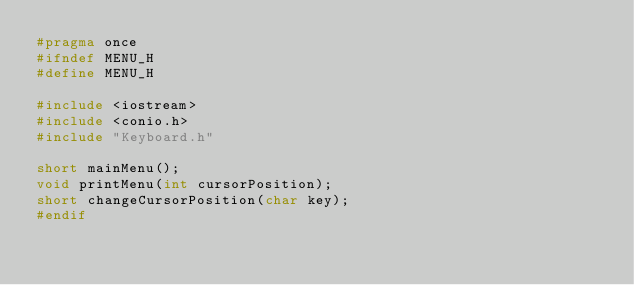<code> <loc_0><loc_0><loc_500><loc_500><_C_>#pragma once
#ifndef MENU_H
#define MENU_H

#include <iostream>
#include <conio.h>
#include "Keyboard.h"

short mainMenu();
void printMenu(int cursorPosition);
short changeCursorPosition(char key);
#endif
</code> 